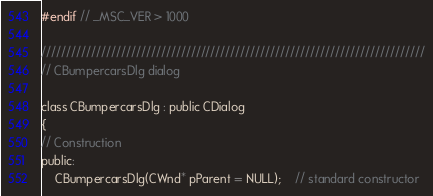Convert code to text. <code><loc_0><loc_0><loc_500><loc_500><_C_>#endif // _MSC_VER > 1000

/////////////////////////////////////////////////////////////////////////////
// CBumpercarsDlg dialog

class CBumpercarsDlg : public CDialog
{
// Construction
public:
	CBumpercarsDlg(CWnd* pParent = NULL);	// standard constructor
</code> 